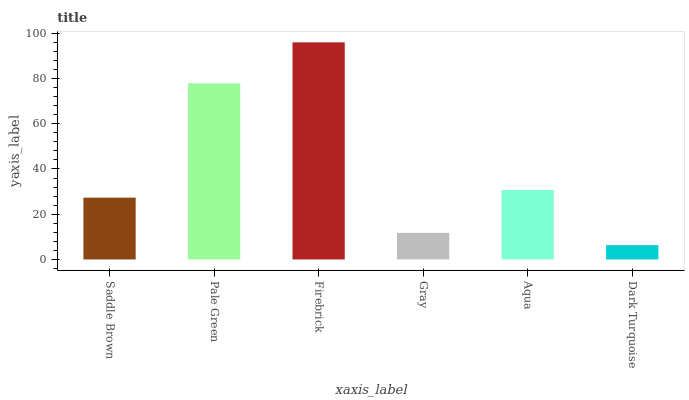Is Dark Turquoise the minimum?
Answer yes or no. Yes. Is Firebrick the maximum?
Answer yes or no. Yes. Is Pale Green the minimum?
Answer yes or no. No. Is Pale Green the maximum?
Answer yes or no. No. Is Pale Green greater than Saddle Brown?
Answer yes or no. Yes. Is Saddle Brown less than Pale Green?
Answer yes or no. Yes. Is Saddle Brown greater than Pale Green?
Answer yes or no. No. Is Pale Green less than Saddle Brown?
Answer yes or no. No. Is Aqua the high median?
Answer yes or no. Yes. Is Saddle Brown the low median?
Answer yes or no. Yes. Is Pale Green the high median?
Answer yes or no. No. Is Firebrick the low median?
Answer yes or no. No. 